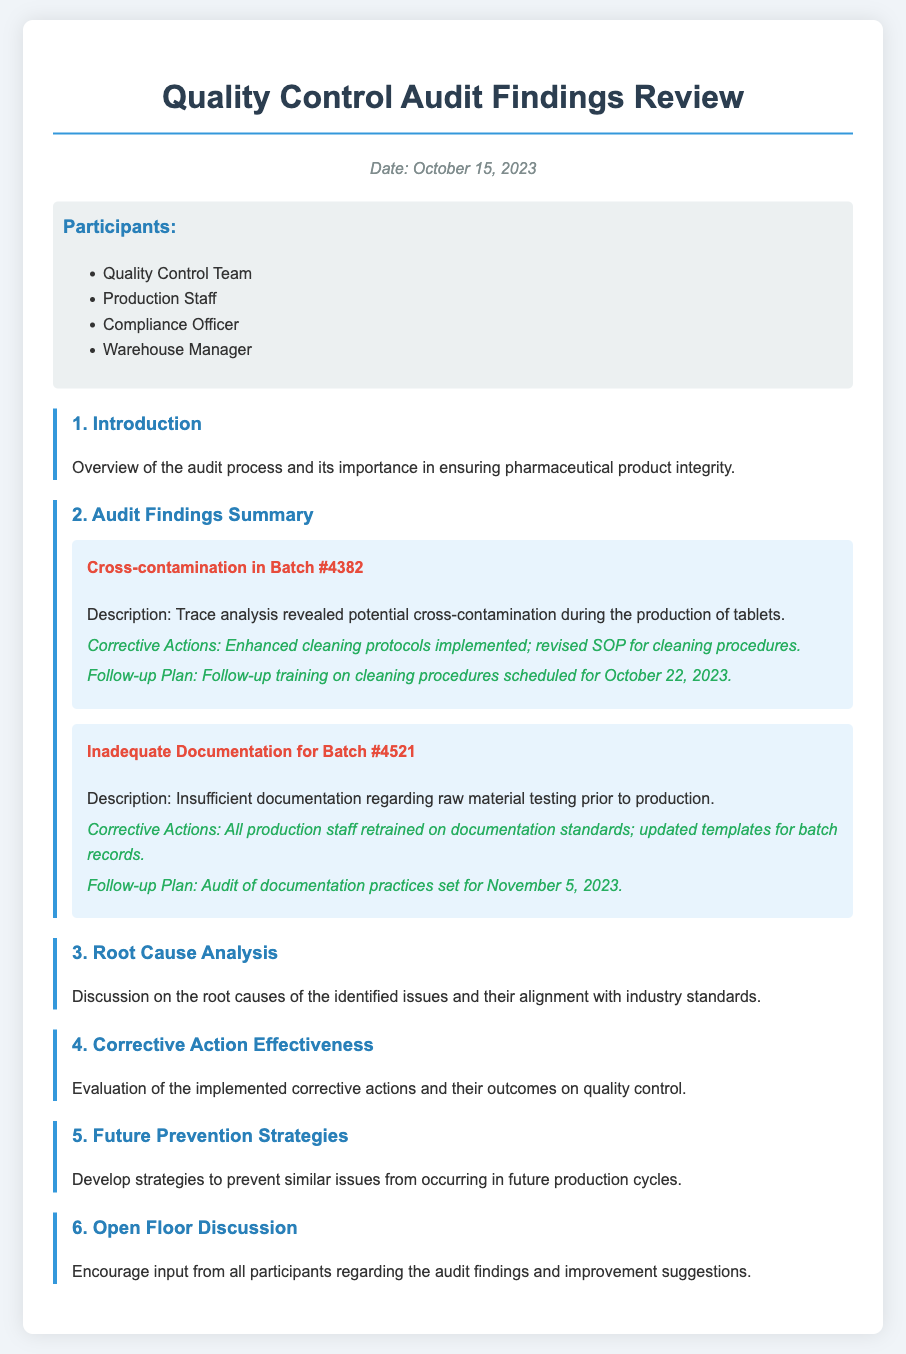what was the date of the Quality Control Audit Findings Review? The date is provided in the document header section.
Answer: October 15, 2023 who was responsible for the corrective actions related to cross-contamination? The corrective actions are described in the audit finding specific to cross-contamination.
Answer: Enhanced cleaning protocols implemented; revised SOP for cleaning procedures what batch number was associated with inadequate documentation? The batch number is stated explicitly under the audit findings section.
Answer: #4521 when is the follow-up training on cleaning procedures scheduled? The follow-up plan includes a specific date for training mentioned in the audit finding.
Answer: October 22, 2023 how many participants were listed in the document? The number of participants is mentioned in the list format provided in the document.
Answer: Four participants what type of issue was found in Batch #4382? The specific issue related to this batch is clearly stated in the audit finding.
Answer: Cross-contamination what corrective action was taken regarding documentation standards? Corrective actions related to documentation standards are specified in the audit finding section for Batch #4521.
Answer: All production staff retrained on documentation standards; updated templates for batch records when is the audit of documentation practices scheduled? The schedule for auditing practices is included in the follow-up plan outlined in the findings.
Answer: November 5, 2023 